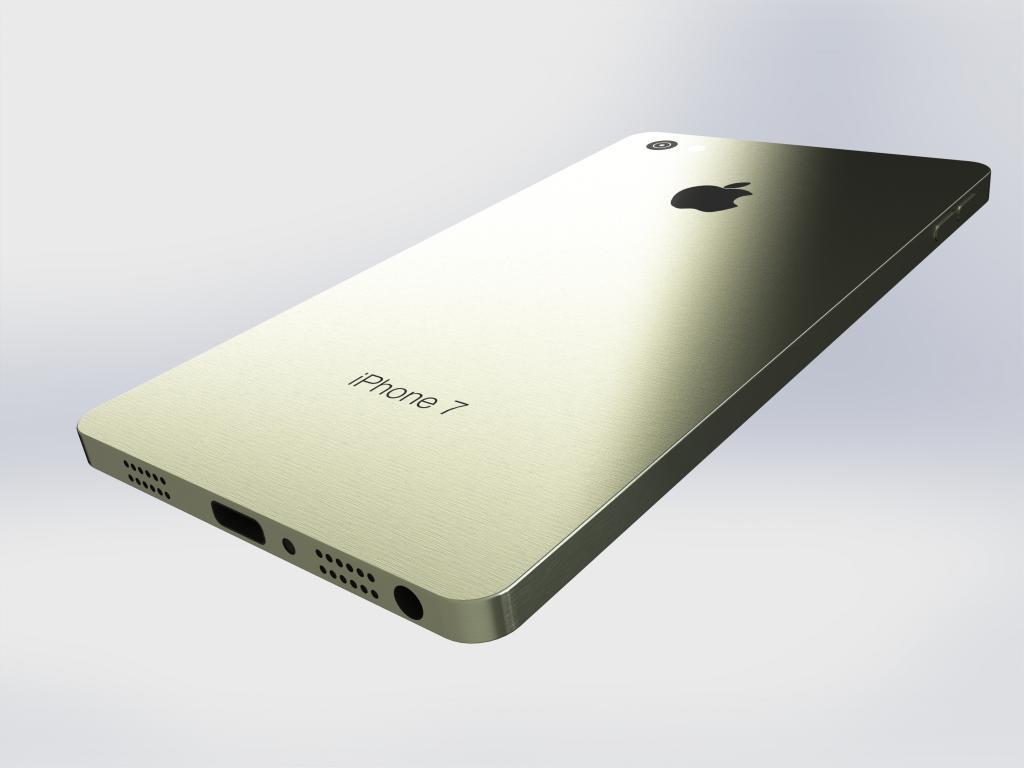<image>
Relay a brief, clear account of the picture shown. the word iPhone that is on a phone 